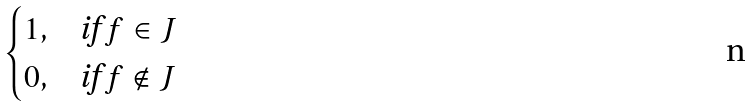<formula> <loc_0><loc_0><loc_500><loc_500>\begin{cases} 1 , & \text {if } f \in J \\ 0 , & \text {if } f \not \in J \\ \end{cases}</formula> 